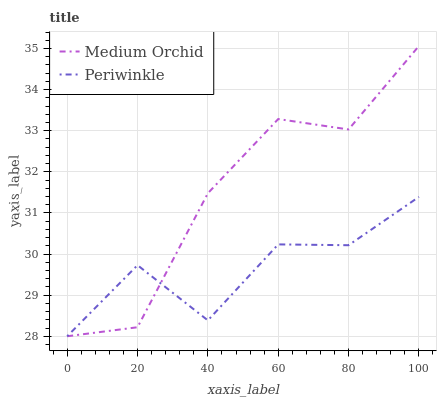Does Periwinkle have the minimum area under the curve?
Answer yes or no. Yes. Does Medium Orchid have the maximum area under the curve?
Answer yes or no. Yes. Does Periwinkle have the maximum area under the curve?
Answer yes or no. No. Is Medium Orchid the smoothest?
Answer yes or no. Yes. Is Periwinkle the roughest?
Answer yes or no. Yes. Is Periwinkle the smoothest?
Answer yes or no. No. Does Medium Orchid have the lowest value?
Answer yes or no. Yes. Does Medium Orchid have the highest value?
Answer yes or no. Yes. Does Periwinkle have the highest value?
Answer yes or no. No. Does Medium Orchid intersect Periwinkle?
Answer yes or no. Yes. Is Medium Orchid less than Periwinkle?
Answer yes or no. No. Is Medium Orchid greater than Periwinkle?
Answer yes or no. No. 